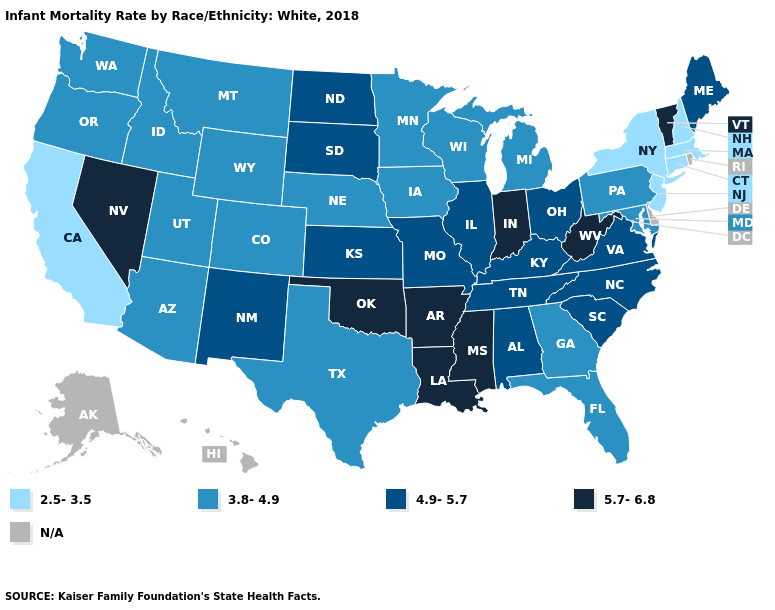What is the value of Georgia?
Be succinct. 3.8-4.9. What is the lowest value in the USA?
Give a very brief answer. 2.5-3.5. Which states have the lowest value in the MidWest?
Quick response, please. Iowa, Michigan, Minnesota, Nebraska, Wisconsin. What is the lowest value in the USA?
Write a very short answer. 2.5-3.5. Does Massachusetts have the lowest value in the USA?
Answer briefly. Yes. What is the lowest value in states that border Missouri?
Quick response, please. 3.8-4.9. Name the states that have a value in the range 4.9-5.7?
Keep it brief. Alabama, Illinois, Kansas, Kentucky, Maine, Missouri, New Mexico, North Carolina, North Dakota, Ohio, South Carolina, South Dakota, Tennessee, Virginia. What is the highest value in the USA?
Give a very brief answer. 5.7-6.8. Name the states that have a value in the range 4.9-5.7?
Give a very brief answer. Alabama, Illinois, Kansas, Kentucky, Maine, Missouri, New Mexico, North Carolina, North Dakota, Ohio, South Carolina, South Dakota, Tennessee, Virginia. What is the value of West Virginia?
Quick response, please. 5.7-6.8. Among the states that border Tennessee , which have the highest value?
Be succinct. Arkansas, Mississippi. Name the states that have a value in the range 2.5-3.5?
Answer briefly. California, Connecticut, Massachusetts, New Hampshire, New Jersey, New York. Name the states that have a value in the range 4.9-5.7?
Concise answer only. Alabama, Illinois, Kansas, Kentucky, Maine, Missouri, New Mexico, North Carolina, North Dakota, Ohio, South Carolina, South Dakota, Tennessee, Virginia. Does Massachusetts have the highest value in the USA?
Quick response, please. No. How many symbols are there in the legend?
Be succinct. 5. 